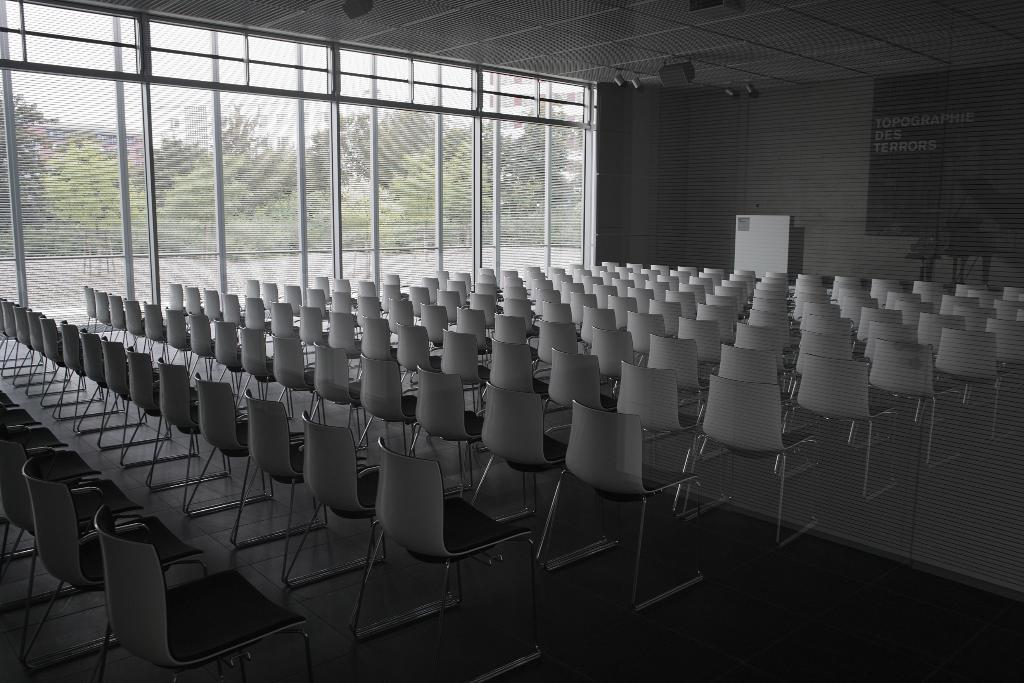What type of furniture is present in the image? There are chairs in the image. What color are the chairs? The chairs are white. What is on the left side of the image? There is a glass wall on the left side of the image. What can be seen outside the glass wall? Green trees are visible outside the glass wall. How many forks are lying on the chairs in the image? There are no forks present in the image. What type of rabbits can be seen hopping around the chairs in the image? There are no rabbits present in the image. 